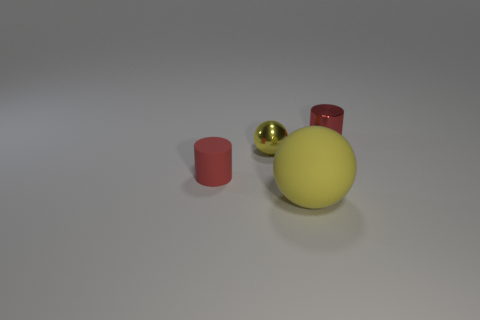Add 4 small shiny balls. How many objects exist? 8 Subtract 0 green cylinders. How many objects are left? 4 Subtract all brown shiny blocks. Subtract all tiny metal cylinders. How many objects are left? 3 Add 1 small yellow objects. How many small yellow objects are left? 2 Add 2 big gray things. How many big gray things exist? 2 